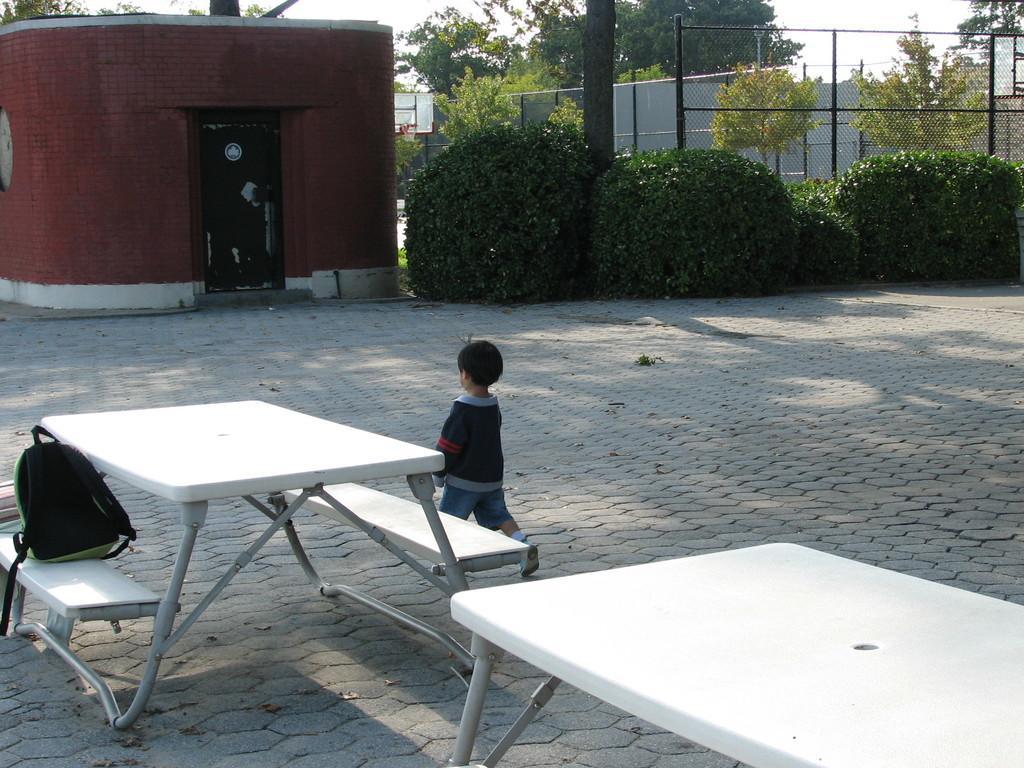In one or two sentences, can you explain what this image depicts? This is a picture of outside of the house. In the center we have a boy. The boy is walking like slowly. There is a table and bench. There is a bag on a bench. We can see in the background there is a tree and sky. 